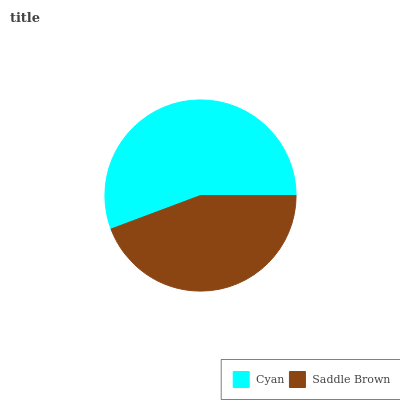Is Saddle Brown the minimum?
Answer yes or no. Yes. Is Cyan the maximum?
Answer yes or no. Yes. Is Saddle Brown the maximum?
Answer yes or no. No. Is Cyan greater than Saddle Brown?
Answer yes or no. Yes. Is Saddle Brown less than Cyan?
Answer yes or no. Yes. Is Saddle Brown greater than Cyan?
Answer yes or no. No. Is Cyan less than Saddle Brown?
Answer yes or no. No. Is Cyan the high median?
Answer yes or no. Yes. Is Saddle Brown the low median?
Answer yes or no. Yes. Is Saddle Brown the high median?
Answer yes or no. No. Is Cyan the low median?
Answer yes or no. No. 